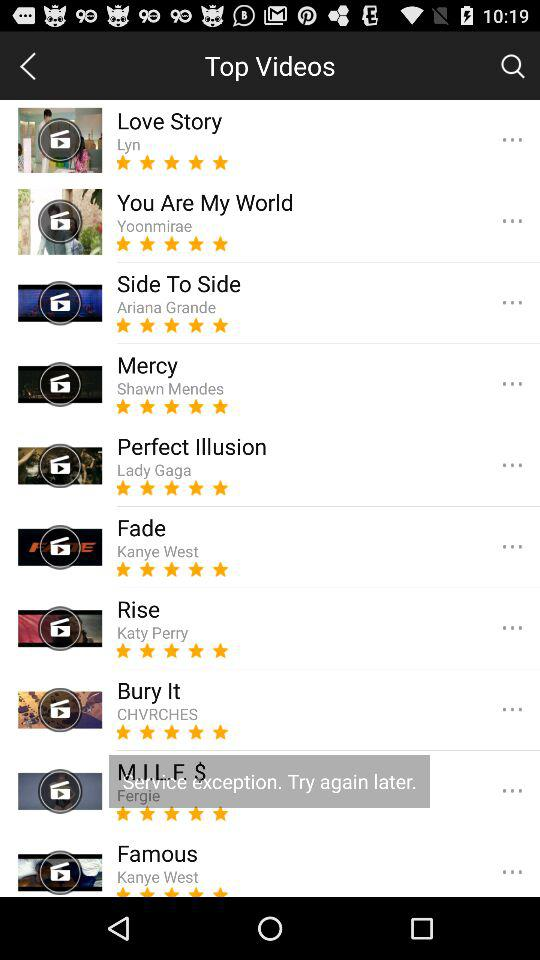What song features Kanye West as the lead singer? The songs are "Fade" and "Famous". 